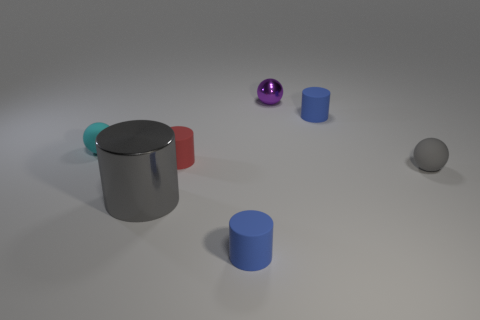Add 2 small shiny things. How many objects exist? 9 Subtract all cylinders. How many objects are left? 3 Subtract all tiny cylinders. Subtract all tiny spheres. How many objects are left? 1 Add 1 objects. How many objects are left? 8 Add 2 tiny matte objects. How many tiny matte objects exist? 7 Subtract 0 green blocks. How many objects are left? 7 